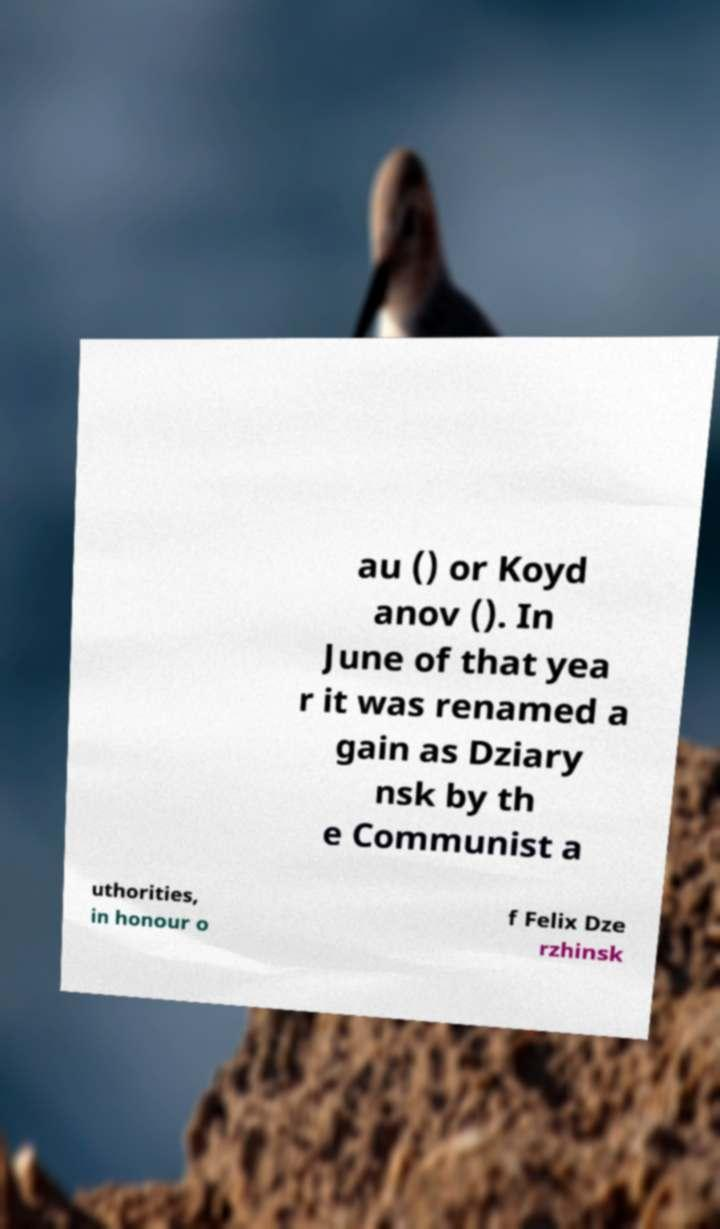Please identify and transcribe the text found in this image. au () or Koyd anov (). In June of that yea r it was renamed a gain as Dziary nsk by th e Communist a uthorities, in honour o f Felix Dze rzhinsk 